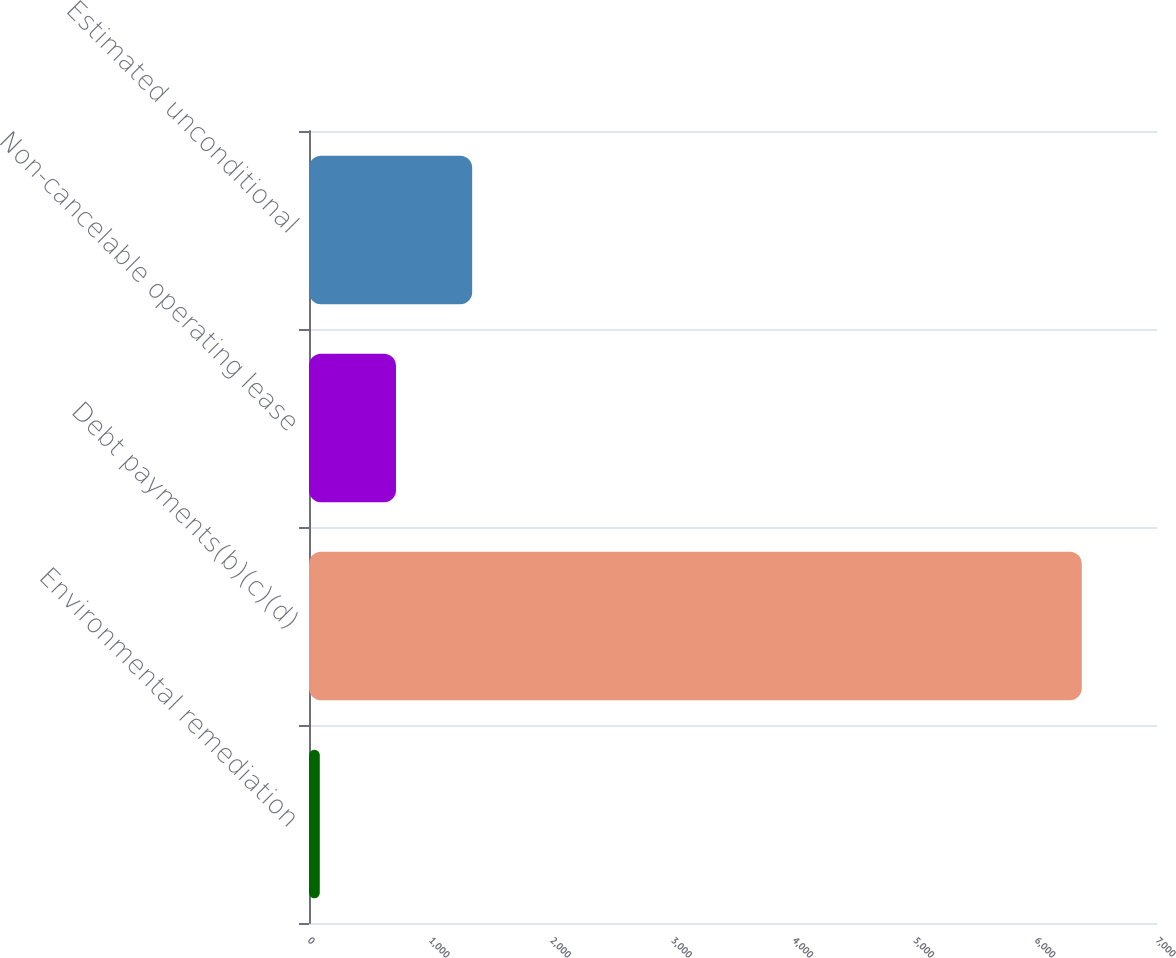<chart> <loc_0><loc_0><loc_500><loc_500><bar_chart><fcel>Environmental remediation<fcel>Debt payments(b)(c)(d)<fcel>Non-cancelable operating lease<fcel>Estimated unconditional<nl><fcel>89<fcel>6379<fcel>718<fcel>1347<nl></chart> 